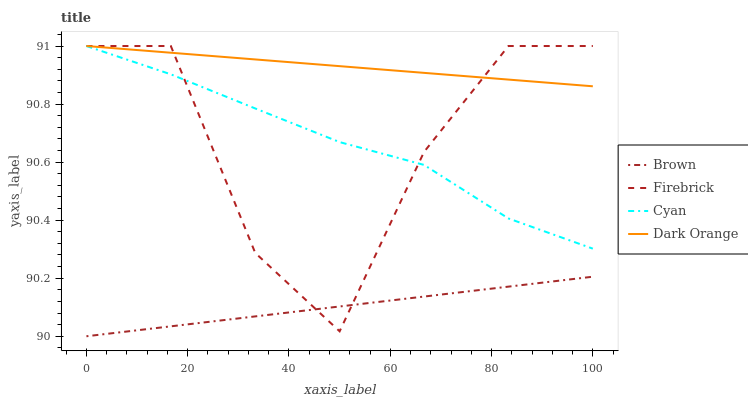Does Brown have the minimum area under the curve?
Answer yes or no. Yes. Does Dark Orange have the maximum area under the curve?
Answer yes or no. Yes. Does Firebrick have the minimum area under the curve?
Answer yes or no. No. Does Firebrick have the maximum area under the curve?
Answer yes or no. No. Is Brown the smoothest?
Answer yes or no. Yes. Is Firebrick the roughest?
Answer yes or no. Yes. Is Firebrick the smoothest?
Answer yes or no. No. Is Brown the roughest?
Answer yes or no. No. Does Brown have the lowest value?
Answer yes or no. Yes. Does Firebrick have the lowest value?
Answer yes or no. No. Does Cyan have the highest value?
Answer yes or no. Yes. Does Brown have the highest value?
Answer yes or no. No. Is Brown less than Cyan?
Answer yes or no. Yes. Is Dark Orange greater than Brown?
Answer yes or no. Yes. Does Cyan intersect Dark Orange?
Answer yes or no. Yes. Is Cyan less than Dark Orange?
Answer yes or no. No. Is Cyan greater than Dark Orange?
Answer yes or no. No. Does Brown intersect Cyan?
Answer yes or no. No. 